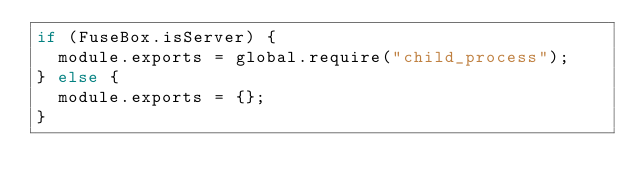<code> <loc_0><loc_0><loc_500><loc_500><_JavaScript_>if (FuseBox.isServer) {
	module.exports = global.require("child_process");
} else {
	module.exports = {};
}
</code> 